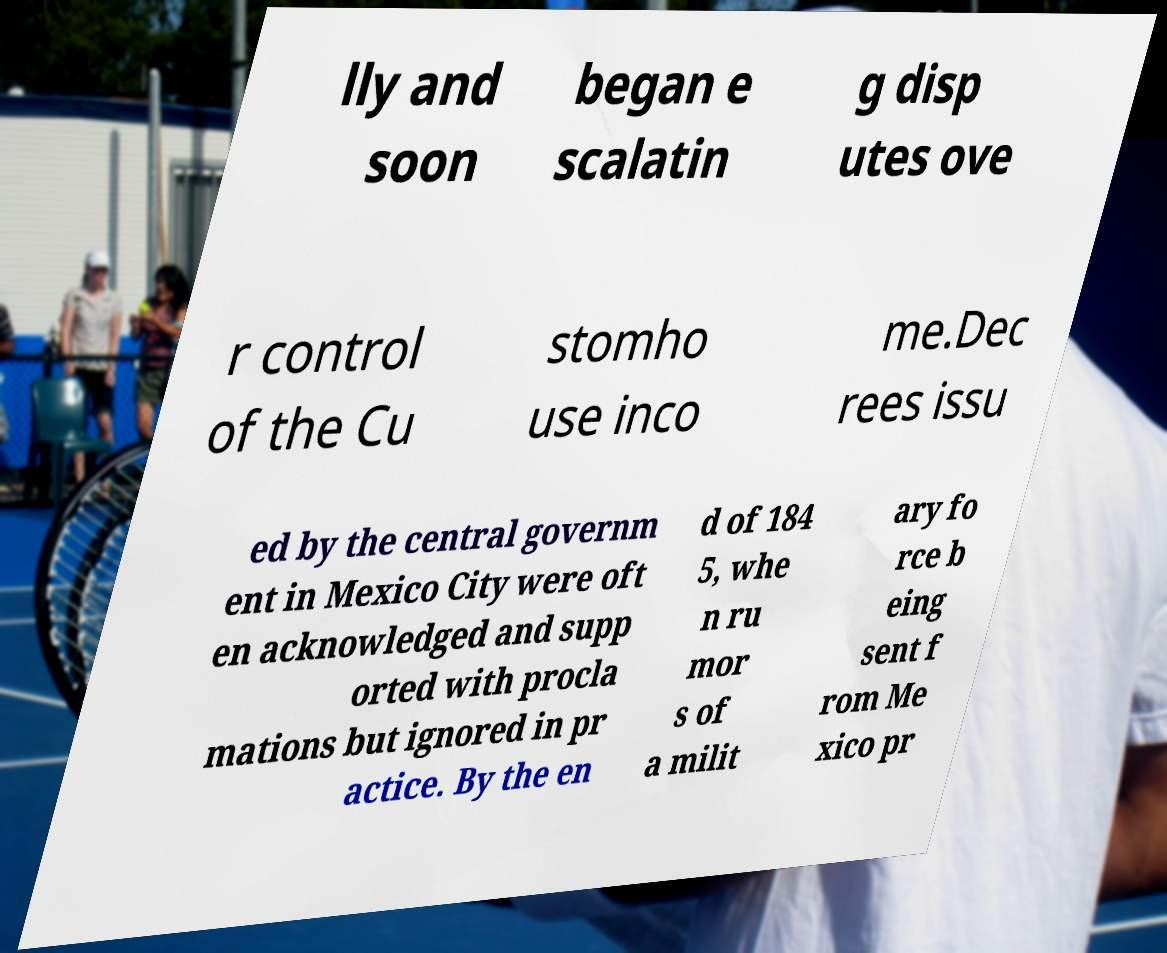Please read and relay the text visible in this image. What does it say? lly and soon began e scalatin g disp utes ove r control of the Cu stomho use inco me.Dec rees issu ed by the central governm ent in Mexico City were oft en acknowledged and supp orted with procla mations but ignored in pr actice. By the en d of 184 5, whe n ru mor s of a milit ary fo rce b eing sent f rom Me xico pr 